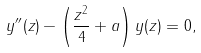<formula> <loc_0><loc_0><loc_500><loc_500>y ^ { \prime \prime } ( z ) - \left ( \frac { z ^ { 2 } } { 4 } + a \right ) y ( z ) = 0 ,</formula> 